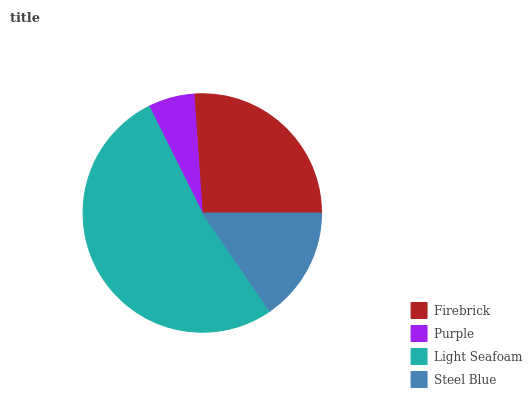Is Purple the minimum?
Answer yes or no. Yes. Is Light Seafoam the maximum?
Answer yes or no. Yes. Is Light Seafoam the minimum?
Answer yes or no. No. Is Purple the maximum?
Answer yes or no. No. Is Light Seafoam greater than Purple?
Answer yes or no. Yes. Is Purple less than Light Seafoam?
Answer yes or no. Yes. Is Purple greater than Light Seafoam?
Answer yes or no. No. Is Light Seafoam less than Purple?
Answer yes or no. No. Is Firebrick the high median?
Answer yes or no. Yes. Is Steel Blue the low median?
Answer yes or no. Yes. Is Light Seafoam the high median?
Answer yes or no. No. Is Light Seafoam the low median?
Answer yes or no. No. 